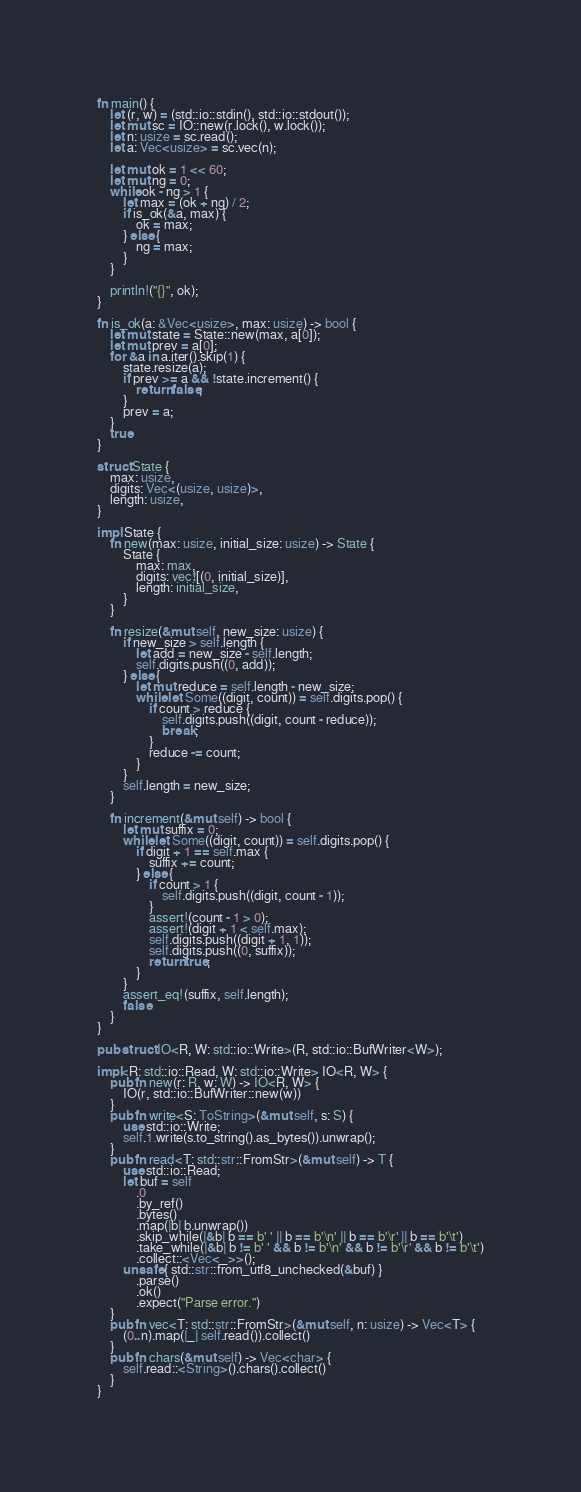Convert code to text. <code><loc_0><loc_0><loc_500><loc_500><_Rust_>fn main() {
    let (r, w) = (std::io::stdin(), std::io::stdout());
    let mut sc = IO::new(r.lock(), w.lock());
    let n: usize = sc.read();
    let a: Vec<usize> = sc.vec(n);

    let mut ok = 1 << 60;
    let mut ng = 0;
    while ok - ng > 1 {
        let max = (ok + ng) / 2;
        if is_ok(&a, max) {
            ok = max;
        } else {
            ng = max;
        }
    }

    println!("{}", ok);
}

fn is_ok(a: &Vec<usize>, max: usize) -> bool {
    let mut state = State::new(max, a[0]);
    let mut prev = a[0];
    for &a in a.iter().skip(1) {
        state.resize(a);
        if prev >= a && !state.increment() {
            return false;
        }
        prev = a;
    }
    true
}

struct State {
    max: usize,
    digits: Vec<(usize, usize)>,
    length: usize,
}

impl State {
    fn new(max: usize, initial_size: usize) -> State {
        State {
            max: max,
            digits: vec![(0, initial_size)],
            length: initial_size,
        }
    }

    fn resize(&mut self, new_size: usize) {
        if new_size > self.length {
            let add = new_size - self.length;
            self.digits.push((0, add));
        } else {
            let mut reduce = self.length - new_size;
            while let Some((digit, count)) = self.digits.pop() {
                if count > reduce {
                    self.digits.push((digit, count - reduce));
                    break;
                }
                reduce -= count;
            }
        }
        self.length = new_size;
    }

    fn increment(&mut self) -> bool {
        let mut suffix = 0;
        while let Some((digit, count)) = self.digits.pop() {
            if digit + 1 == self.max {
                suffix += count;
            } else {
                if count > 1 {
                    self.digits.push((digit, count - 1));
                }
                assert!(count - 1 > 0);
                assert!(digit + 1 < self.max);
                self.digits.push((digit + 1, 1));
                self.digits.push((0, suffix));
                return true;
            }
        }
        assert_eq!(suffix, self.length);
        false
    }
}

pub struct IO<R, W: std::io::Write>(R, std::io::BufWriter<W>);

impl<R: std::io::Read, W: std::io::Write> IO<R, W> {
    pub fn new(r: R, w: W) -> IO<R, W> {
        IO(r, std::io::BufWriter::new(w))
    }
    pub fn write<S: ToString>(&mut self, s: S) {
        use std::io::Write;
        self.1.write(s.to_string().as_bytes()).unwrap();
    }
    pub fn read<T: std::str::FromStr>(&mut self) -> T {
        use std::io::Read;
        let buf = self
            .0
            .by_ref()
            .bytes()
            .map(|b| b.unwrap())
            .skip_while(|&b| b == b' ' || b == b'\n' || b == b'\r' || b == b'\t')
            .take_while(|&b| b != b' ' && b != b'\n' && b != b'\r' && b != b'\t')
            .collect::<Vec<_>>();
        unsafe { std::str::from_utf8_unchecked(&buf) }
            .parse()
            .ok()
            .expect("Parse error.")
    }
    pub fn vec<T: std::str::FromStr>(&mut self, n: usize) -> Vec<T> {
        (0..n).map(|_| self.read()).collect()
    }
    pub fn chars(&mut self) -> Vec<char> {
        self.read::<String>().chars().collect()
    }
}
</code> 